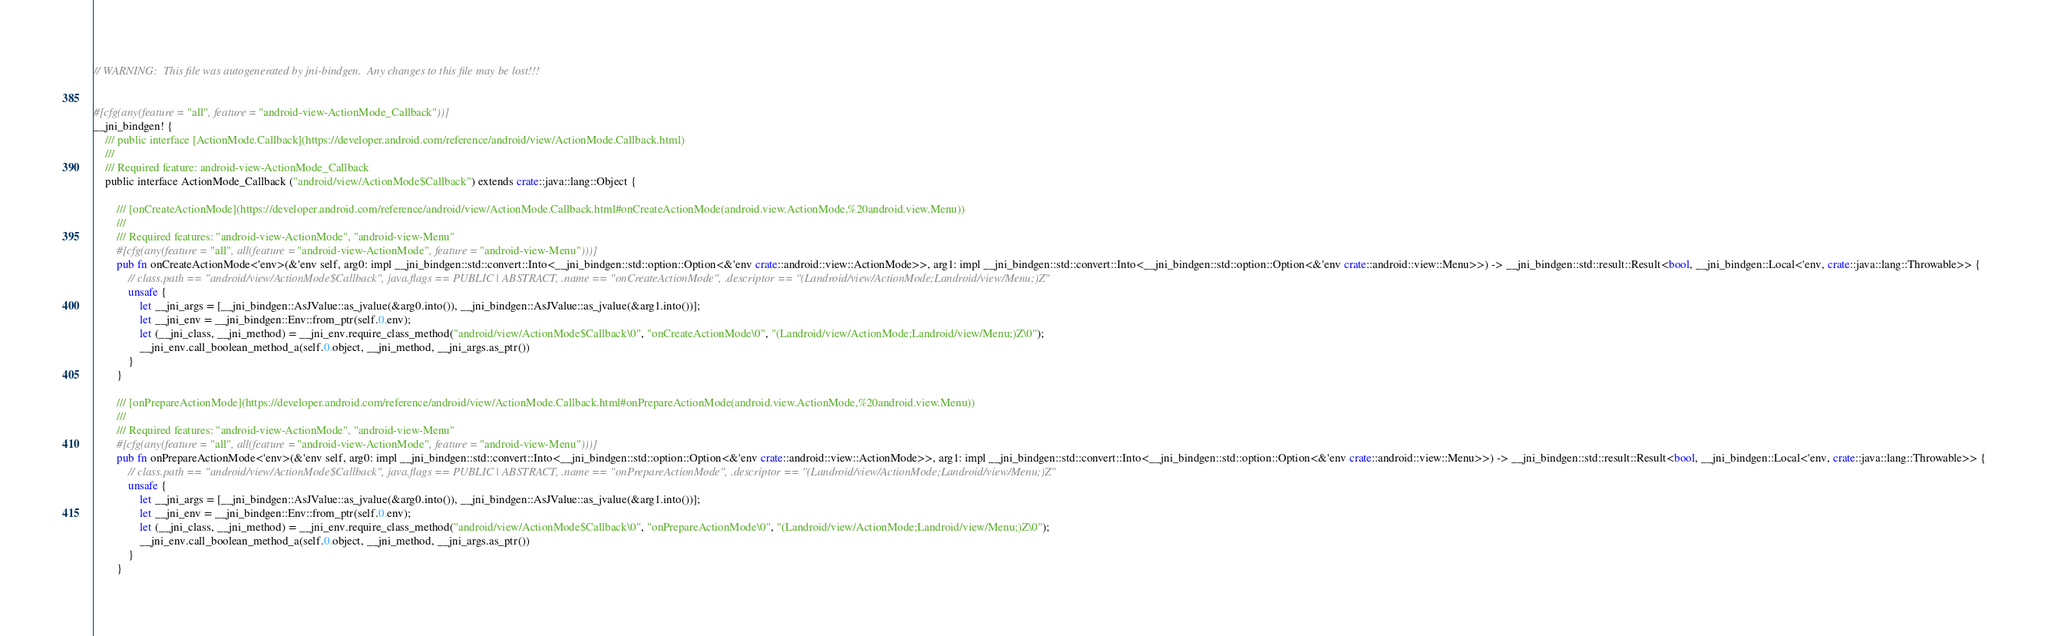Convert code to text. <code><loc_0><loc_0><loc_500><loc_500><_Rust_>// WARNING:  This file was autogenerated by jni-bindgen.  Any changes to this file may be lost!!!


#[cfg(any(feature = "all", feature = "android-view-ActionMode_Callback"))]
__jni_bindgen! {
    /// public interface [ActionMode.Callback](https://developer.android.com/reference/android/view/ActionMode.Callback.html)
    ///
    /// Required feature: android-view-ActionMode_Callback
    public interface ActionMode_Callback ("android/view/ActionMode$Callback") extends crate::java::lang::Object {

        /// [onCreateActionMode](https://developer.android.com/reference/android/view/ActionMode.Callback.html#onCreateActionMode(android.view.ActionMode,%20android.view.Menu))
        ///
        /// Required features: "android-view-ActionMode", "android-view-Menu"
        #[cfg(any(feature = "all", all(feature = "android-view-ActionMode", feature = "android-view-Menu")))]
        pub fn onCreateActionMode<'env>(&'env self, arg0: impl __jni_bindgen::std::convert::Into<__jni_bindgen::std::option::Option<&'env crate::android::view::ActionMode>>, arg1: impl __jni_bindgen::std::convert::Into<__jni_bindgen::std::option::Option<&'env crate::android::view::Menu>>) -> __jni_bindgen::std::result::Result<bool, __jni_bindgen::Local<'env, crate::java::lang::Throwable>> {
            // class.path == "android/view/ActionMode$Callback", java.flags == PUBLIC | ABSTRACT, .name == "onCreateActionMode", .descriptor == "(Landroid/view/ActionMode;Landroid/view/Menu;)Z"
            unsafe {
                let __jni_args = [__jni_bindgen::AsJValue::as_jvalue(&arg0.into()), __jni_bindgen::AsJValue::as_jvalue(&arg1.into())];
                let __jni_env = __jni_bindgen::Env::from_ptr(self.0.env);
                let (__jni_class, __jni_method) = __jni_env.require_class_method("android/view/ActionMode$Callback\0", "onCreateActionMode\0", "(Landroid/view/ActionMode;Landroid/view/Menu;)Z\0");
                __jni_env.call_boolean_method_a(self.0.object, __jni_method, __jni_args.as_ptr())
            }
        }

        /// [onPrepareActionMode](https://developer.android.com/reference/android/view/ActionMode.Callback.html#onPrepareActionMode(android.view.ActionMode,%20android.view.Menu))
        ///
        /// Required features: "android-view-ActionMode", "android-view-Menu"
        #[cfg(any(feature = "all", all(feature = "android-view-ActionMode", feature = "android-view-Menu")))]
        pub fn onPrepareActionMode<'env>(&'env self, arg0: impl __jni_bindgen::std::convert::Into<__jni_bindgen::std::option::Option<&'env crate::android::view::ActionMode>>, arg1: impl __jni_bindgen::std::convert::Into<__jni_bindgen::std::option::Option<&'env crate::android::view::Menu>>) -> __jni_bindgen::std::result::Result<bool, __jni_bindgen::Local<'env, crate::java::lang::Throwable>> {
            // class.path == "android/view/ActionMode$Callback", java.flags == PUBLIC | ABSTRACT, .name == "onPrepareActionMode", .descriptor == "(Landroid/view/ActionMode;Landroid/view/Menu;)Z"
            unsafe {
                let __jni_args = [__jni_bindgen::AsJValue::as_jvalue(&arg0.into()), __jni_bindgen::AsJValue::as_jvalue(&arg1.into())];
                let __jni_env = __jni_bindgen::Env::from_ptr(self.0.env);
                let (__jni_class, __jni_method) = __jni_env.require_class_method("android/view/ActionMode$Callback\0", "onPrepareActionMode\0", "(Landroid/view/ActionMode;Landroid/view/Menu;)Z\0");
                __jni_env.call_boolean_method_a(self.0.object, __jni_method, __jni_args.as_ptr())
            }
        }
</code> 